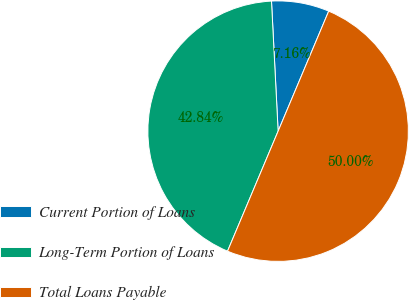Convert chart to OTSL. <chart><loc_0><loc_0><loc_500><loc_500><pie_chart><fcel>Current Portion of Loans<fcel>Long-Term Portion of Loans<fcel>Total Loans Payable<nl><fcel>7.16%<fcel>42.84%<fcel>50.0%<nl></chart> 